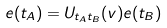Convert formula to latex. <formula><loc_0><loc_0><loc_500><loc_500>e ( t _ { A } ) = U _ { t _ { A } t _ { B } } ( v ) e ( t _ { B } )</formula> 